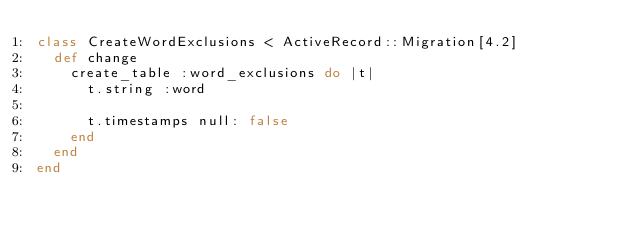Convert code to text. <code><loc_0><loc_0><loc_500><loc_500><_Ruby_>class CreateWordExclusions < ActiveRecord::Migration[4.2]
  def change
    create_table :word_exclusions do |t|
      t.string :word

      t.timestamps null: false
    end
  end
end
</code> 